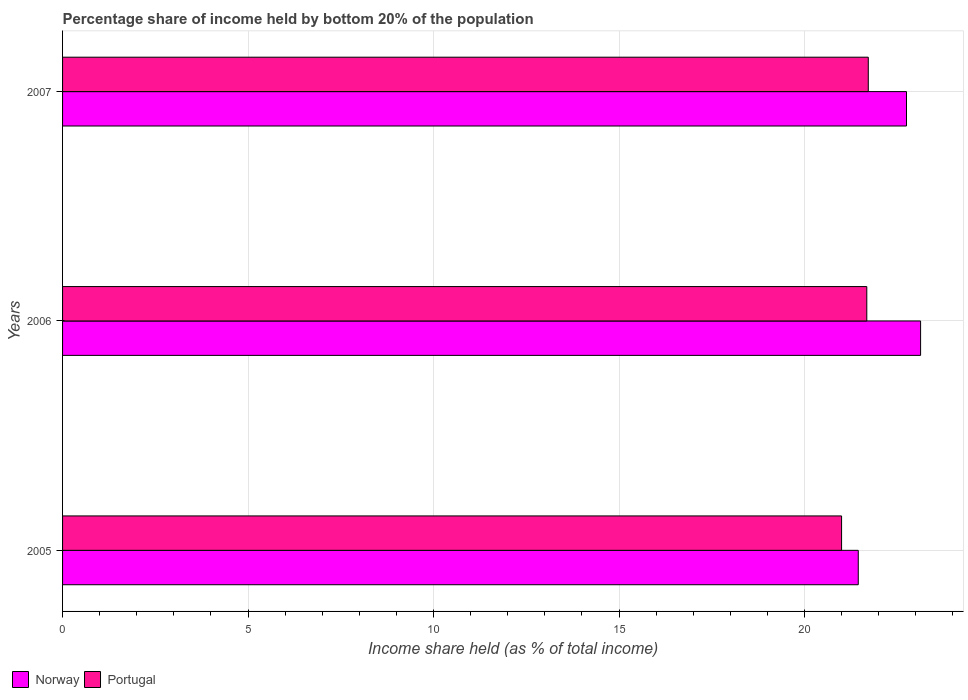How many bars are there on the 1st tick from the top?
Offer a very short reply. 2. What is the label of the 3rd group of bars from the top?
Provide a short and direct response. 2005. In how many cases, is the number of bars for a given year not equal to the number of legend labels?
Your answer should be very brief. 0. Across all years, what is the maximum share of income held by bottom 20% of the population in Norway?
Provide a succinct answer. 23.13. Across all years, what is the minimum share of income held by bottom 20% of the population in Portugal?
Your response must be concise. 21. What is the total share of income held by bottom 20% of the population in Norway in the graph?
Your response must be concise. 67.33. What is the difference between the share of income held by bottom 20% of the population in Norway in 2006 and that in 2007?
Offer a terse response. 0.38. What is the difference between the share of income held by bottom 20% of the population in Portugal in 2005 and the share of income held by bottom 20% of the population in Norway in 2007?
Offer a very short reply. -1.75. What is the average share of income held by bottom 20% of the population in Portugal per year?
Provide a succinct answer. 21.47. In the year 2006, what is the difference between the share of income held by bottom 20% of the population in Portugal and share of income held by bottom 20% of the population in Norway?
Provide a short and direct response. -1.45. In how many years, is the share of income held by bottom 20% of the population in Portugal greater than 4 %?
Give a very brief answer. 3. What is the ratio of the share of income held by bottom 20% of the population in Portugal in 2005 to that in 2006?
Make the answer very short. 0.97. Is the difference between the share of income held by bottom 20% of the population in Portugal in 2006 and 2007 greater than the difference between the share of income held by bottom 20% of the population in Norway in 2006 and 2007?
Give a very brief answer. No. What is the difference between the highest and the second highest share of income held by bottom 20% of the population in Norway?
Your answer should be very brief. 0.38. What is the difference between the highest and the lowest share of income held by bottom 20% of the population in Norway?
Offer a very short reply. 1.68. How many bars are there?
Your answer should be very brief. 6. How many years are there in the graph?
Provide a short and direct response. 3. What is the difference between two consecutive major ticks on the X-axis?
Provide a short and direct response. 5. Are the values on the major ticks of X-axis written in scientific E-notation?
Your answer should be compact. No. Does the graph contain any zero values?
Your answer should be very brief. No. Does the graph contain grids?
Keep it short and to the point. Yes. Where does the legend appear in the graph?
Provide a short and direct response. Bottom left. How are the legend labels stacked?
Make the answer very short. Horizontal. What is the title of the graph?
Keep it short and to the point. Percentage share of income held by bottom 20% of the population. What is the label or title of the X-axis?
Provide a short and direct response. Income share held (as % of total income). What is the Income share held (as % of total income) of Norway in 2005?
Make the answer very short. 21.45. What is the Income share held (as % of total income) in Norway in 2006?
Ensure brevity in your answer.  23.13. What is the Income share held (as % of total income) in Portugal in 2006?
Your answer should be compact. 21.68. What is the Income share held (as % of total income) in Norway in 2007?
Your response must be concise. 22.75. What is the Income share held (as % of total income) in Portugal in 2007?
Ensure brevity in your answer.  21.72. Across all years, what is the maximum Income share held (as % of total income) of Norway?
Your response must be concise. 23.13. Across all years, what is the maximum Income share held (as % of total income) in Portugal?
Your answer should be compact. 21.72. Across all years, what is the minimum Income share held (as % of total income) in Norway?
Keep it short and to the point. 21.45. What is the total Income share held (as % of total income) in Norway in the graph?
Keep it short and to the point. 67.33. What is the total Income share held (as % of total income) of Portugal in the graph?
Your response must be concise. 64.4. What is the difference between the Income share held (as % of total income) of Norway in 2005 and that in 2006?
Your answer should be compact. -1.68. What is the difference between the Income share held (as % of total income) of Portugal in 2005 and that in 2006?
Your answer should be very brief. -0.68. What is the difference between the Income share held (as % of total income) in Portugal in 2005 and that in 2007?
Give a very brief answer. -0.72. What is the difference between the Income share held (as % of total income) in Norway in 2006 and that in 2007?
Give a very brief answer. 0.38. What is the difference between the Income share held (as % of total income) of Portugal in 2006 and that in 2007?
Provide a short and direct response. -0.04. What is the difference between the Income share held (as % of total income) in Norway in 2005 and the Income share held (as % of total income) in Portugal in 2006?
Provide a short and direct response. -0.23. What is the difference between the Income share held (as % of total income) of Norway in 2005 and the Income share held (as % of total income) of Portugal in 2007?
Give a very brief answer. -0.27. What is the difference between the Income share held (as % of total income) of Norway in 2006 and the Income share held (as % of total income) of Portugal in 2007?
Keep it short and to the point. 1.41. What is the average Income share held (as % of total income) in Norway per year?
Provide a succinct answer. 22.44. What is the average Income share held (as % of total income) of Portugal per year?
Offer a terse response. 21.47. In the year 2005, what is the difference between the Income share held (as % of total income) of Norway and Income share held (as % of total income) of Portugal?
Provide a succinct answer. 0.45. In the year 2006, what is the difference between the Income share held (as % of total income) in Norway and Income share held (as % of total income) in Portugal?
Make the answer very short. 1.45. In the year 2007, what is the difference between the Income share held (as % of total income) in Norway and Income share held (as % of total income) in Portugal?
Ensure brevity in your answer.  1.03. What is the ratio of the Income share held (as % of total income) of Norway in 2005 to that in 2006?
Your response must be concise. 0.93. What is the ratio of the Income share held (as % of total income) in Portugal in 2005 to that in 2006?
Your answer should be compact. 0.97. What is the ratio of the Income share held (as % of total income) of Norway in 2005 to that in 2007?
Give a very brief answer. 0.94. What is the ratio of the Income share held (as % of total income) of Portugal in 2005 to that in 2007?
Your response must be concise. 0.97. What is the ratio of the Income share held (as % of total income) of Norway in 2006 to that in 2007?
Provide a short and direct response. 1.02. What is the difference between the highest and the second highest Income share held (as % of total income) in Norway?
Keep it short and to the point. 0.38. What is the difference between the highest and the second highest Income share held (as % of total income) of Portugal?
Your answer should be very brief. 0.04. What is the difference between the highest and the lowest Income share held (as % of total income) of Norway?
Provide a succinct answer. 1.68. What is the difference between the highest and the lowest Income share held (as % of total income) of Portugal?
Your response must be concise. 0.72. 